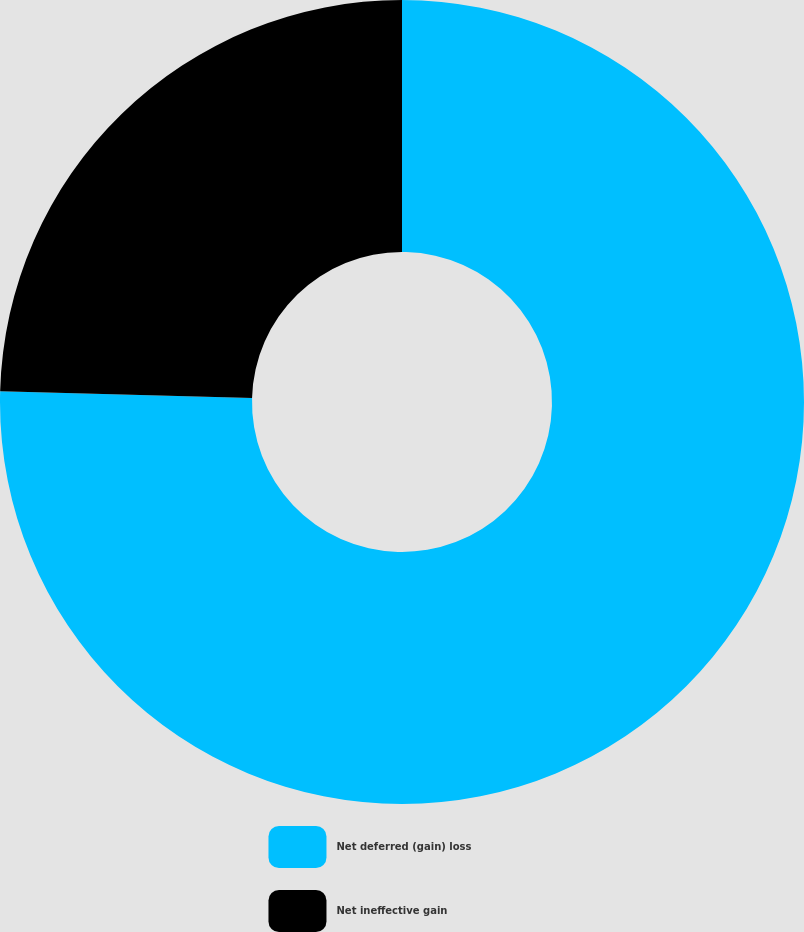Convert chart. <chart><loc_0><loc_0><loc_500><loc_500><pie_chart><fcel>Net deferred (gain) loss<fcel>Net ineffective gain<nl><fcel>75.43%<fcel>24.57%<nl></chart> 